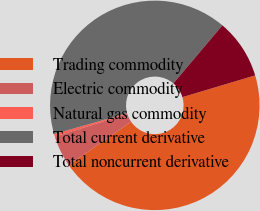Convert chart to OTSL. <chart><loc_0><loc_0><loc_500><loc_500><pie_chart><fcel>Trading commodity<fcel>Electric commodity<fcel>Natural gas commodity<fcel>Total current derivative<fcel>Total noncurrent derivative<nl><fcel>44.98%<fcel>4.81%<fcel>0.41%<fcel>40.58%<fcel>9.22%<nl></chart> 